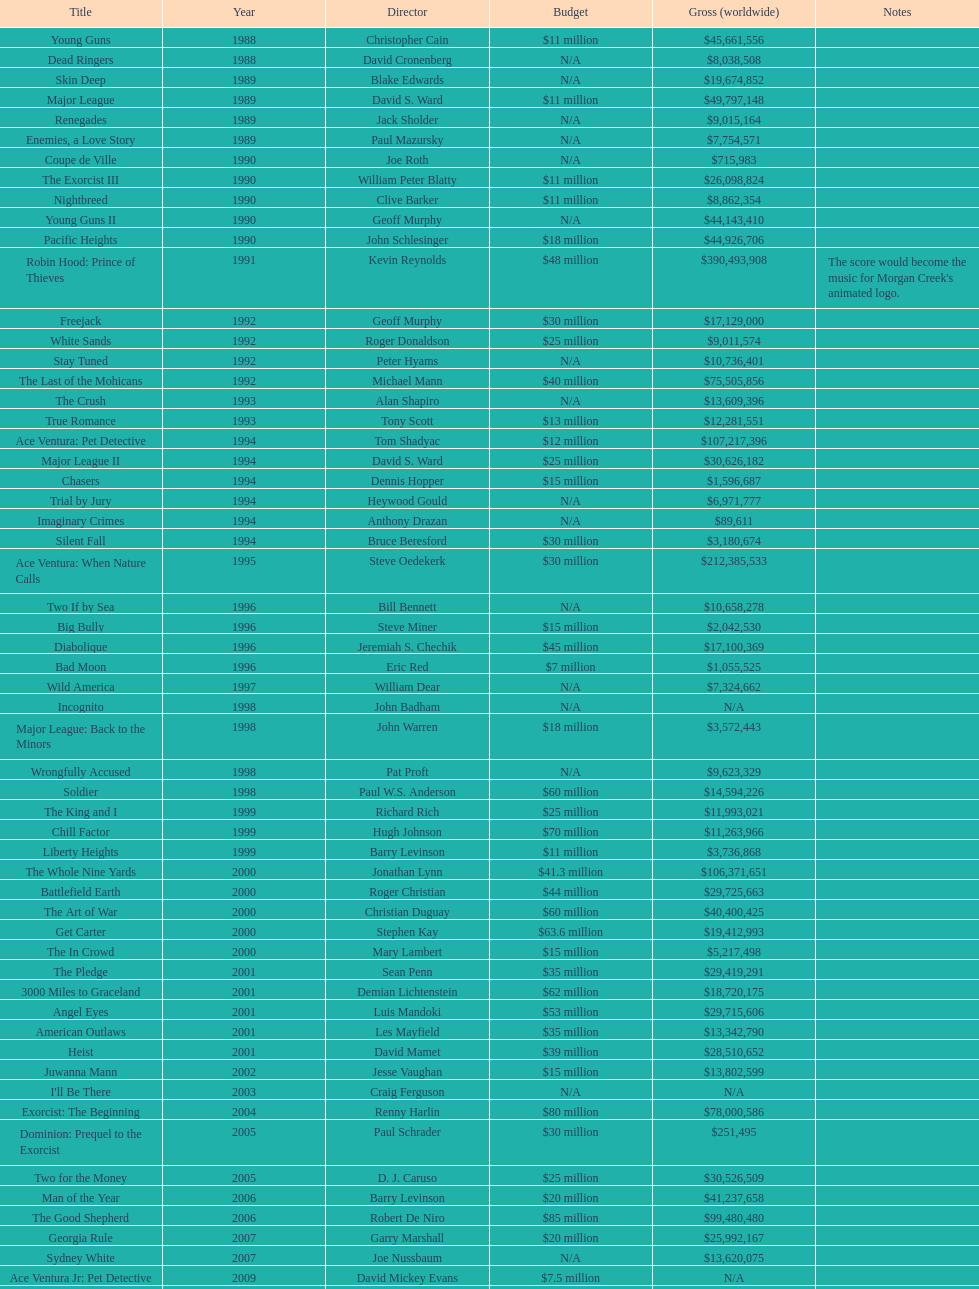What is the top grossing film? Robin Hood: Prince of Thieves. 